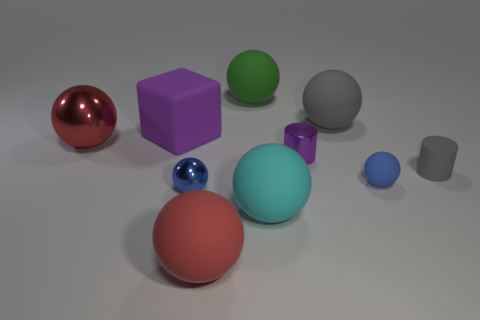The large red thing to the right of the red thing that is to the left of the purple cube is what shape? The large object to the right of the smaller red sphere, which is to the left of the purple cube, is a red sphere as well. Both red spheres share the same shape, having a round, three-dimensional surface, which is characteristic of spheres. 